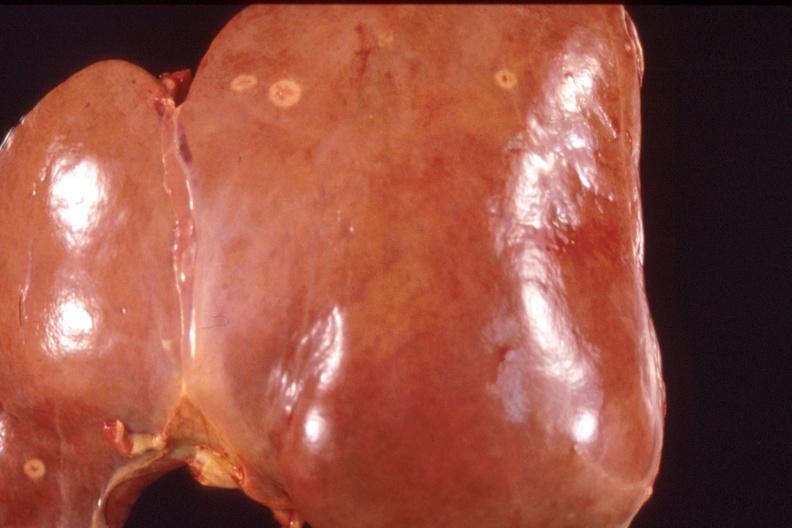what does this image show?
Answer the question using a single word or phrase. Liver 